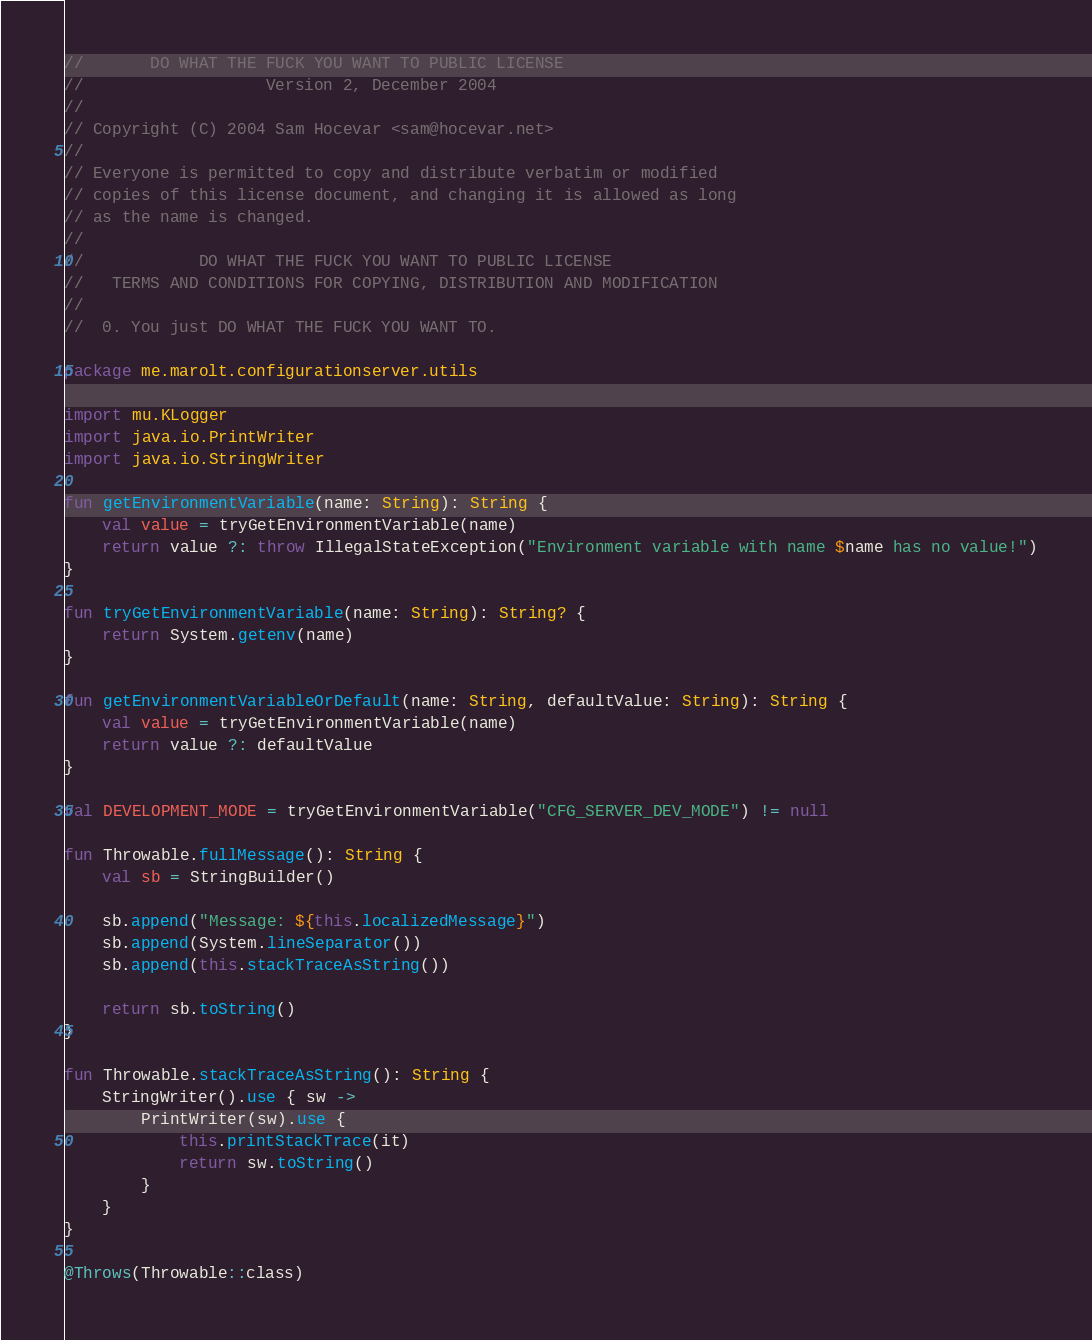Convert code to text. <code><loc_0><loc_0><loc_500><loc_500><_Kotlin_>//       DO WHAT THE FUCK YOU WANT TO PUBLIC LICENSE
//                   Version 2, December 2004
//
// Copyright (C) 2004 Sam Hocevar <sam@hocevar.net>
//
// Everyone is permitted to copy and distribute verbatim or modified
// copies of this license document, and changing it is allowed as long
// as the name is changed.
//
//            DO WHAT THE FUCK YOU WANT TO PUBLIC LICENSE
//   TERMS AND CONDITIONS FOR COPYING, DISTRIBUTION AND MODIFICATION
//
//  0. You just DO WHAT THE FUCK YOU WANT TO.

package me.marolt.configurationserver.utils

import mu.KLogger
import java.io.PrintWriter
import java.io.StringWriter

fun getEnvironmentVariable(name: String): String {
    val value = tryGetEnvironmentVariable(name)
    return value ?: throw IllegalStateException("Environment variable with name $name has no value!")
}

fun tryGetEnvironmentVariable(name: String): String? {
    return System.getenv(name)
}

fun getEnvironmentVariableOrDefault(name: String, defaultValue: String): String {
    val value = tryGetEnvironmentVariable(name)
    return value ?: defaultValue
}

val DEVELOPMENT_MODE = tryGetEnvironmentVariable("CFG_SERVER_DEV_MODE") != null

fun Throwable.fullMessage(): String {
    val sb = StringBuilder()

    sb.append("Message: ${this.localizedMessage}")
    sb.append(System.lineSeparator())
    sb.append(this.stackTraceAsString())

    return sb.toString()
}

fun Throwable.stackTraceAsString(): String {
    StringWriter().use { sw ->
        PrintWriter(sw).use {
            this.printStackTrace(it)
            return sw.toString()
        }
    }
}

@Throws(Throwable::class)</code> 